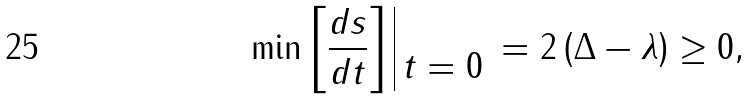<formula> <loc_0><loc_0><loc_500><loc_500>\min \left [ \frac { d s } { d t } \right ] \begin{array} { | c } \\ t = 0 \end{array} = 2 \left ( \Delta - \lambda \right ) \geq 0 ,</formula> 